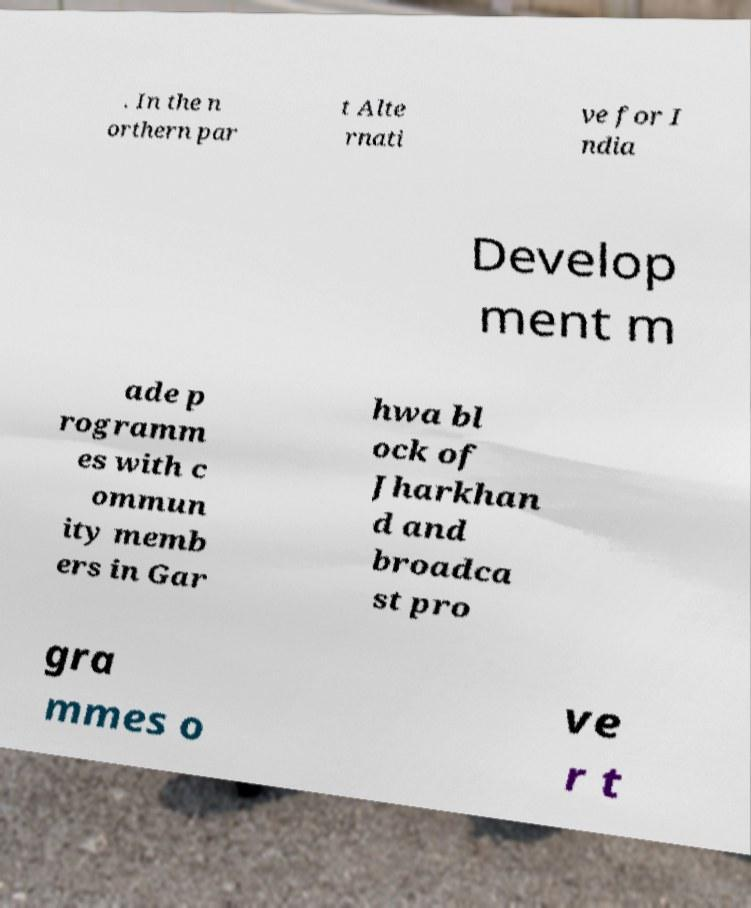Could you assist in decoding the text presented in this image and type it out clearly? . In the n orthern par t Alte rnati ve for I ndia Develop ment m ade p rogramm es with c ommun ity memb ers in Gar hwa bl ock of Jharkhan d and broadca st pro gra mmes o ve r t 